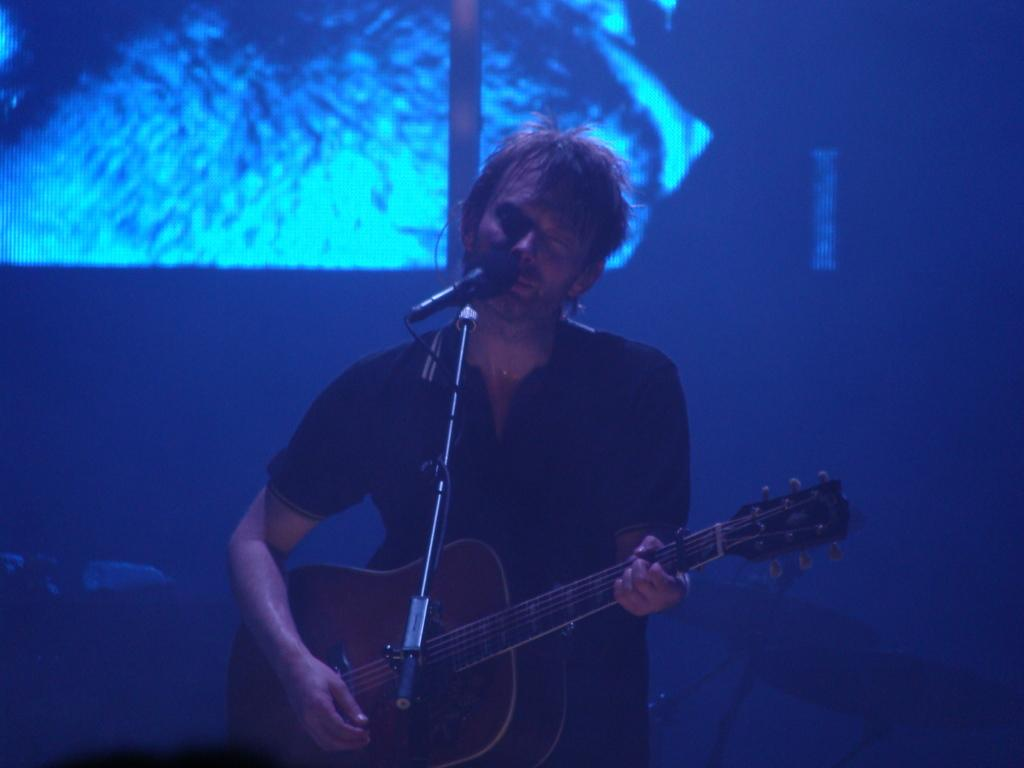What is the main subject of the image? There is a person in the image. What is the person doing in the image? The person is playing a guitar. Is there any equipment related to music in the image? Yes, the person is behind a microphone. What can be said about the person's attire in the image? The person is wearing clothes. What type of flag can be seen in the background of the image? There is no flag present in the image. Can you describe the tail of the person in the image? The person in the image does not have a tail, as they are a human. 